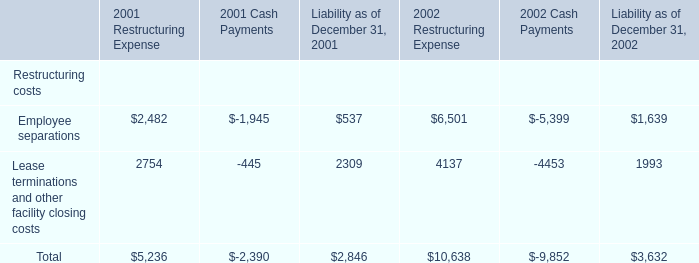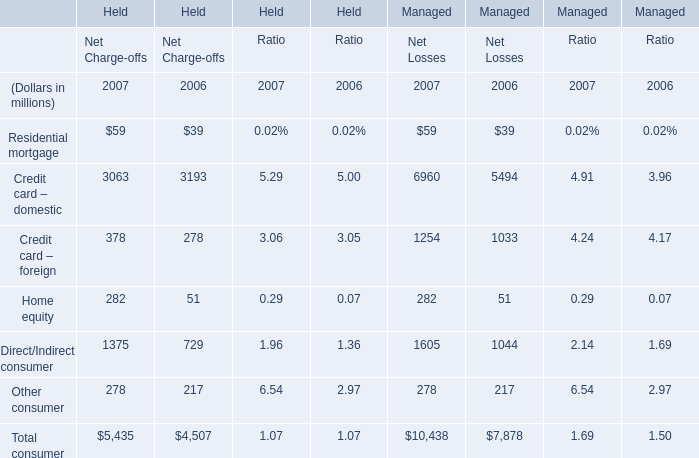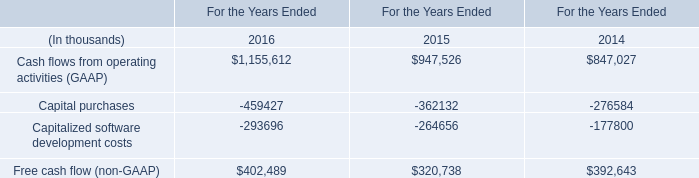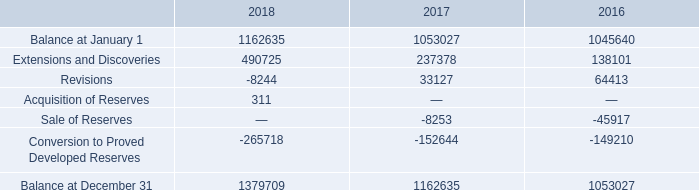What's the total amount of Residential mortgage,Home equity, Credit card – domestic and Credit card – foreign in 2007 for Net Charge-offs? (in million) 
Computations: (((59 + 3063) + 378) + 282)
Answer: 3782.0. 